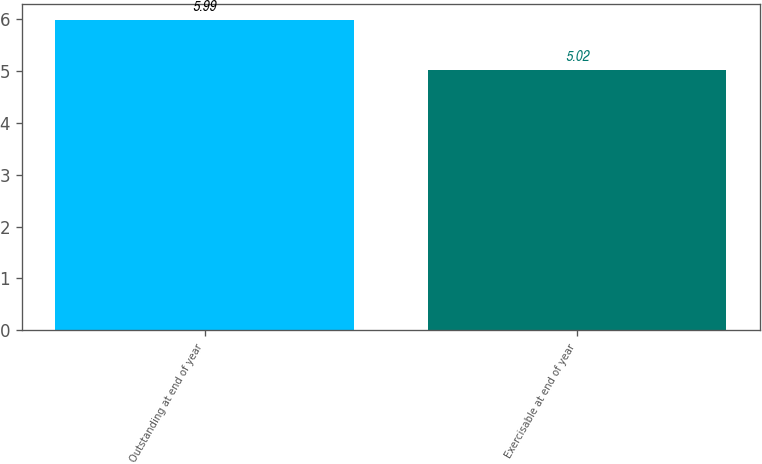Convert chart. <chart><loc_0><loc_0><loc_500><loc_500><bar_chart><fcel>Outstanding at end of year<fcel>Exercisable at end of year<nl><fcel>5.99<fcel>5.02<nl></chart> 